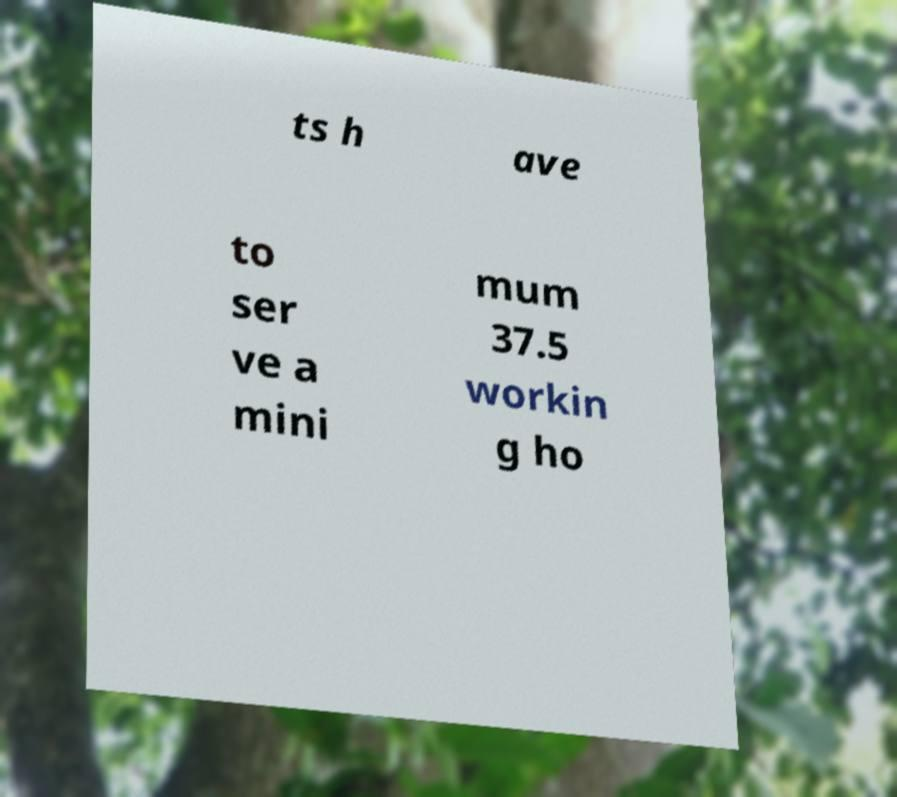What messages or text are displayed in this image? I need them in a readable, typed format. ts h ave to ser ve a mini mum 37.5 workin g ho 